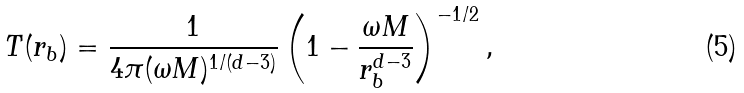Convert formula to latex. <formula><loc_0><loc_0><loc_500><loc_500>T ( r _ { b } ) = \frac { 1 } { 4 \pi ( \omega M ) ^ { 1 / ( d - 3 ) } } \left ( 1 - \frac { \omega M } { r _ { b } ^ { d - 3 } } \right ) ^ { - 1 / 2 } ,</formula> 